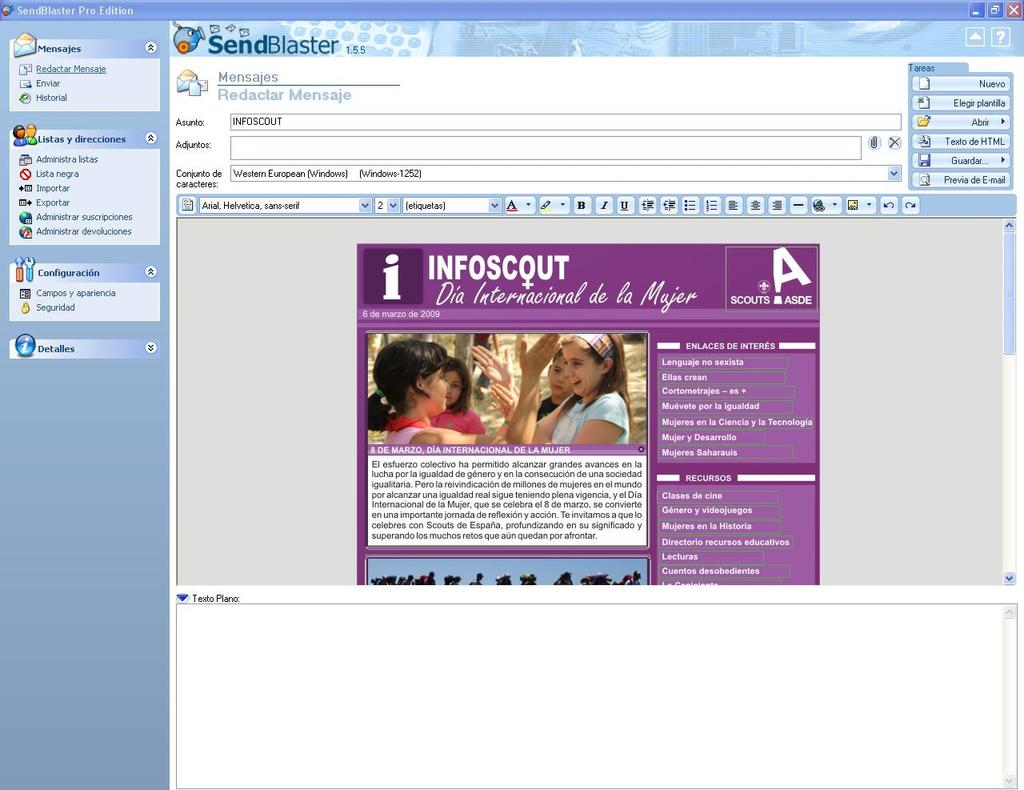What is the main subject of the image? The main subject of the image is a screen. What can be seen on the screen? There is text on the screen. What activity is taking place in the image? There is a group of people in the center of the image, and they are playing something. What type of slope can be seen in the image? There is no slope present in the image; it features a screen with text and a group of people playing something. 